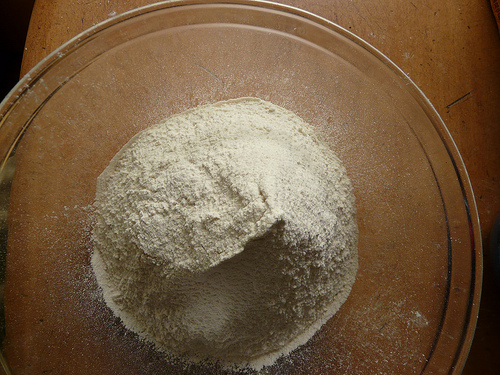<image>
Is the flour on the table? Yes. Looking at the image, I can see the flour is positioned on top of the table, with the table providing support. 